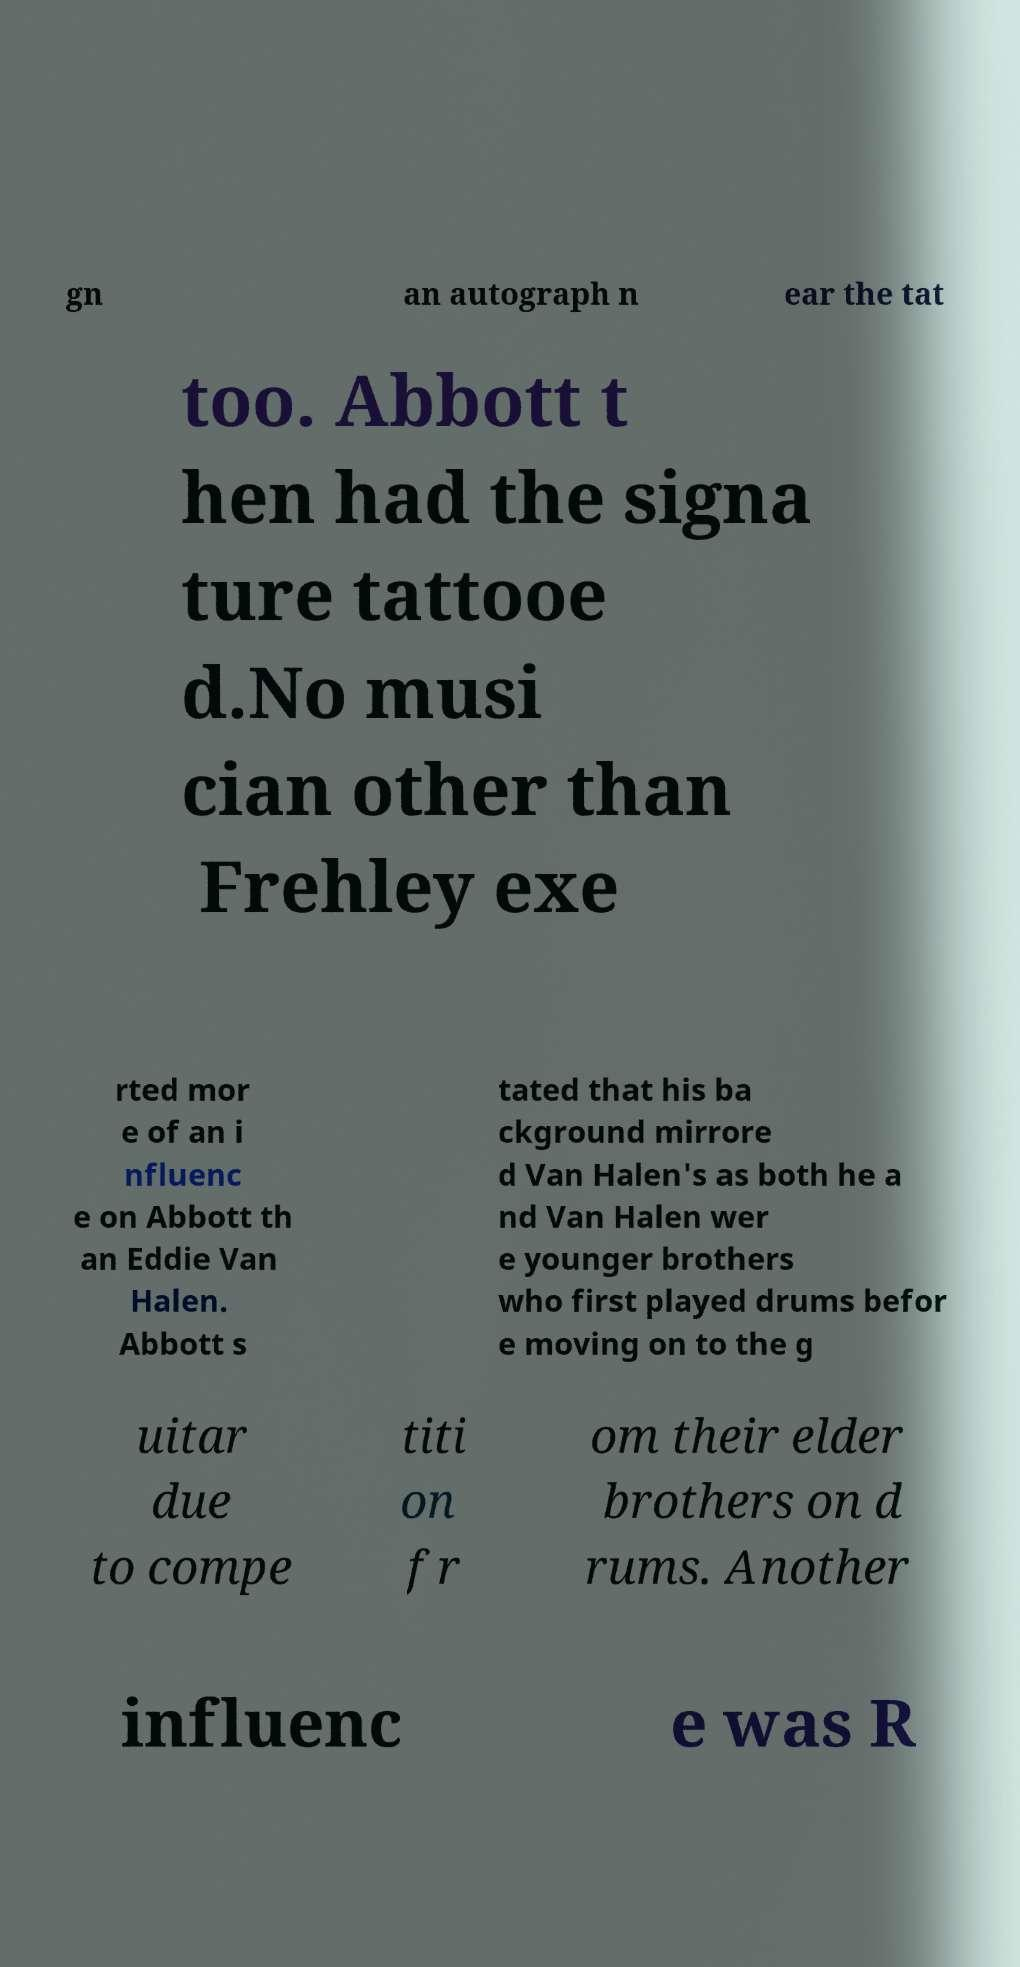Please read and relay the text visible in this image. What does it say? gn an autograph n ear the tat too. Abbott t hen had the signa ture tattooe d.No musi cian other than Frehley exe rted mor e of an i nfluenc e on Abbott th an Eddie Van Halen. Abbott s tated that his ba ckground mirrore d Van Halen's as both he a nd Van Halen wer e younger brothers who first played drums befor e moving on to the g uitar due to compe titi on fr om their elder brothers on d rums. Another influenc e was R 